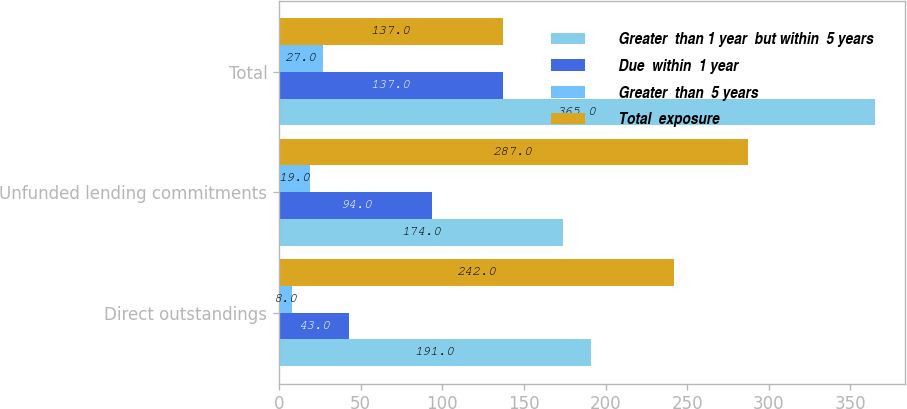Convert chart. <chart><loc_0><loc_0><loc_500><loc_500><stacked_bar_chart><ecel><fcel>Direct outstandings<fcel>Unfunded lending commitments<fcel>Total<nl><fcel>Greater  than 1 year  but within  5 years<fcel>191<fcel>174<fcel>365<nl><fcel>Due  within  1 year<fcel>43<fcel>94<fcel>137<nl><fcel>Greater  than  5 years<fcel>8<fcel>19<fcel>27<nl><fcel>Total  exposure<fcel>242<fcel>287<fcel>137<nl></chart> 